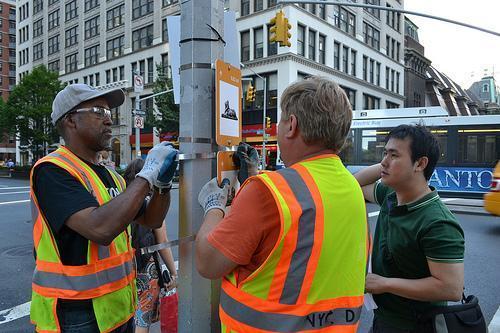How many workers?
Give a very brief answer. 2. 